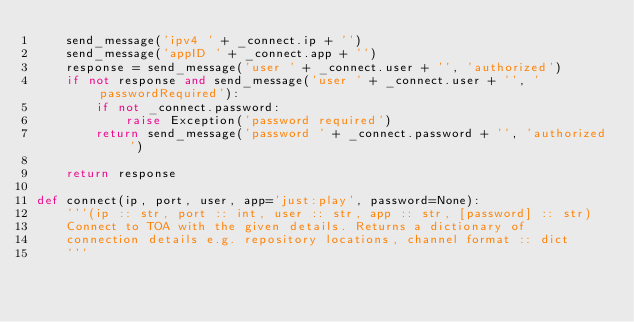Convert code to text. <code><loc_0><loc_0><loc_500><loc_500><_Python_>    send_message('ipv4 ' + _connect.ip + '')
    send_message('appID ' + _connect.app + '')
    response = send_message('user ' + _connect.user + '', 'authorized')
    if not response and send_message('user ' + _connect.user + '', 'passwordRequired'):
        if not _connect.password:
            raise Exception('password required')
        return send_message('password ' + _connect.password + '', 'authorized')

    return response

def connect(ip, port, user, app='just:play', password=None):
    '''(ip :: str, port :: int, user :: str, app :: str, [password] :: str)
    Connect to TOA with the given details. Returns a dictionary of
    connection details e.g. repository locations, channel format :: dict
    '''</code> 